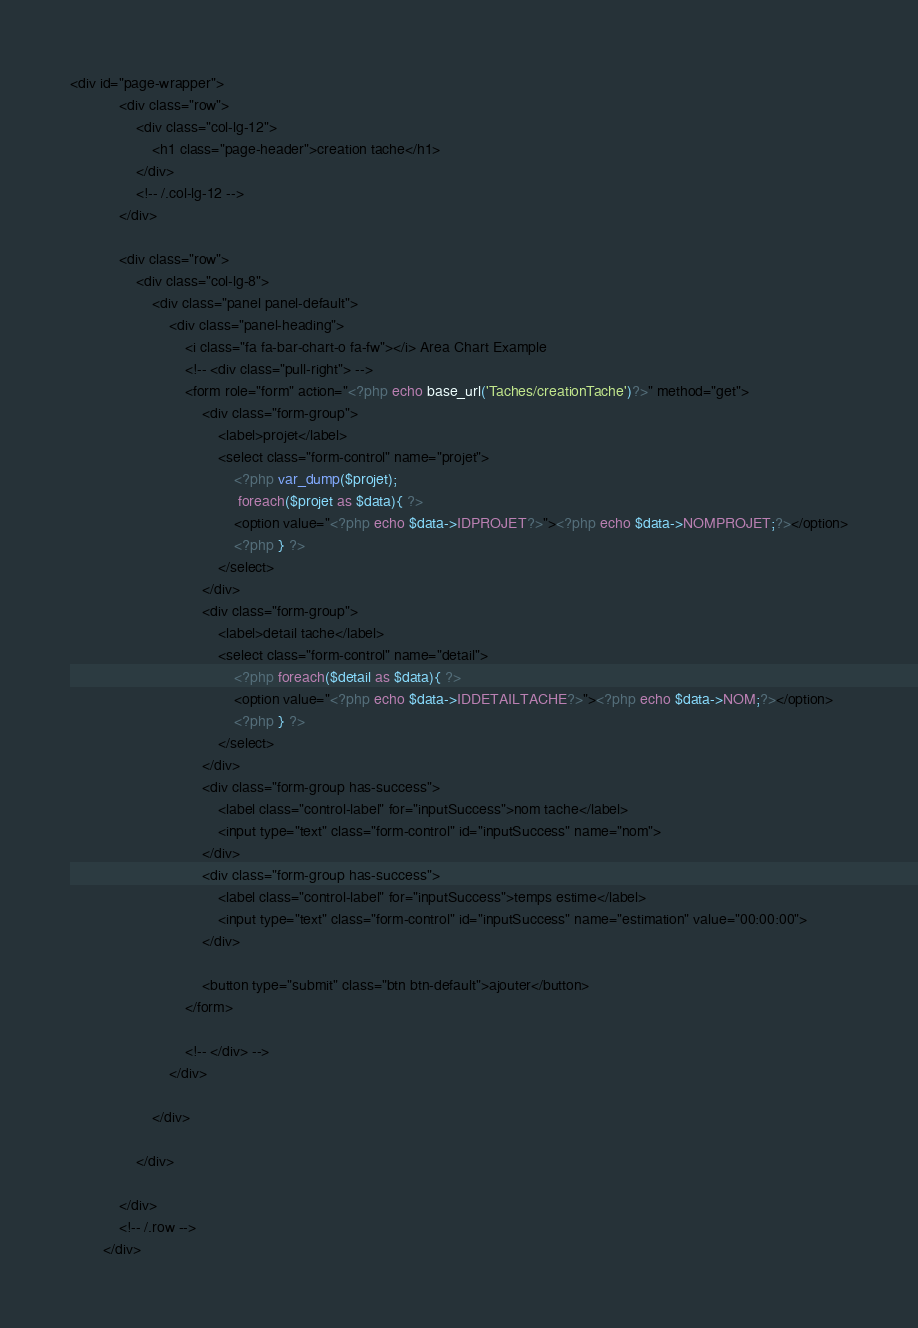Convert code to text. <code><loc_0><loc_0><loc_500><loc_500><_PHP_><div id="page-wrapper">
            <div class="row">
                <div class="col-lg-12">
                    <h1 class="page-header">creation tache</h1>
                </div>
                <!-- /.col-lg-12 -->
            </div>
            
            <div class="row">
                <div class="col-lg-8">
                    <div class="panel panel-default">
                        <div class="panel-heading">
                            <i class="fa fa-bar-chart-o fa-fw"></i> Area Chart Example
                            <!-- <div class="pull-right"> -->
                            <form role="form" action="<?php echo base_url('Taches/creationTache')?>" method="get">
                                <div class="form-group">
                                    <label>projet</label>
                                    <select class="form-control" name="projet">
                                        <?php var_dump($projet);
                                         foreach($projet as $data){ ?>
                                        <option value="<?php echo $data->IDPROJET?>"><?php echo $data->NOMPROJET;?></option>
                                        <?php } ?>
                                    </select>
                                </div>   
                                <div class="form-group">
                                    <label>detail tache</label>
                                    <select class="form-control" name="detail">
                                        <?php foreach($detail as $data){ ?>
                                        <option value="<?php echo $data->IDDETAILTACHE?>"><?php echo $data->NOM;?></option>
                                        <?php } ?>
                                    </select>
                                </div>   
                                <div class="form-group has-success">
                                    <label class="control-label" for="inputSuccess">nom tache</label>
                                    <input type="text" class="form-control" id="inputSuccess" name="nom">
                                </div>
                                <div class="form-group has-success">
                                    <label class="control-label" for="inputSuccess">temps estime</label>
                                    <input type="text" class="form-control" id="inputSuccess" name="estimation" value="00:00:00">
                                </div>
                               
                                <button type="submit" class="btn btn-default">ajouter</button>
                            </form>
                           
                            <!-- </div> -->
                        </div>
                        
                    </div>
                    
                </div>
               
            </div>
            <!-- /.row -->
        </div></code> 